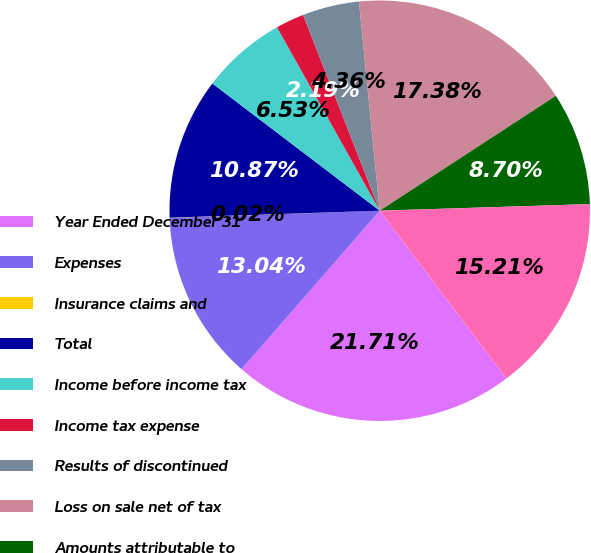<chart> <loc_0><loc_0><loc_500><loc_500><pie_chart><fcel>Year Ended December 31<fcel>Expenses<fcel>Insurance claims and<fcel>Total<fcel>Income before income tax<fcel>Income tax expense<fcel>Results of discontinued<fcel>Loss on sale net of tax<fcel>Amounts attributable to<fcel>Loss from discontinued<nl><fcel>21.71%<fcel>13.04%<fcel>0.02%<fcel>10.87%<fcel>6.53%<fcel>2.19%<fcel>4.36%<fcel>17.38%<fcel>8.7%<fcel>15.21%<nl></chart> 